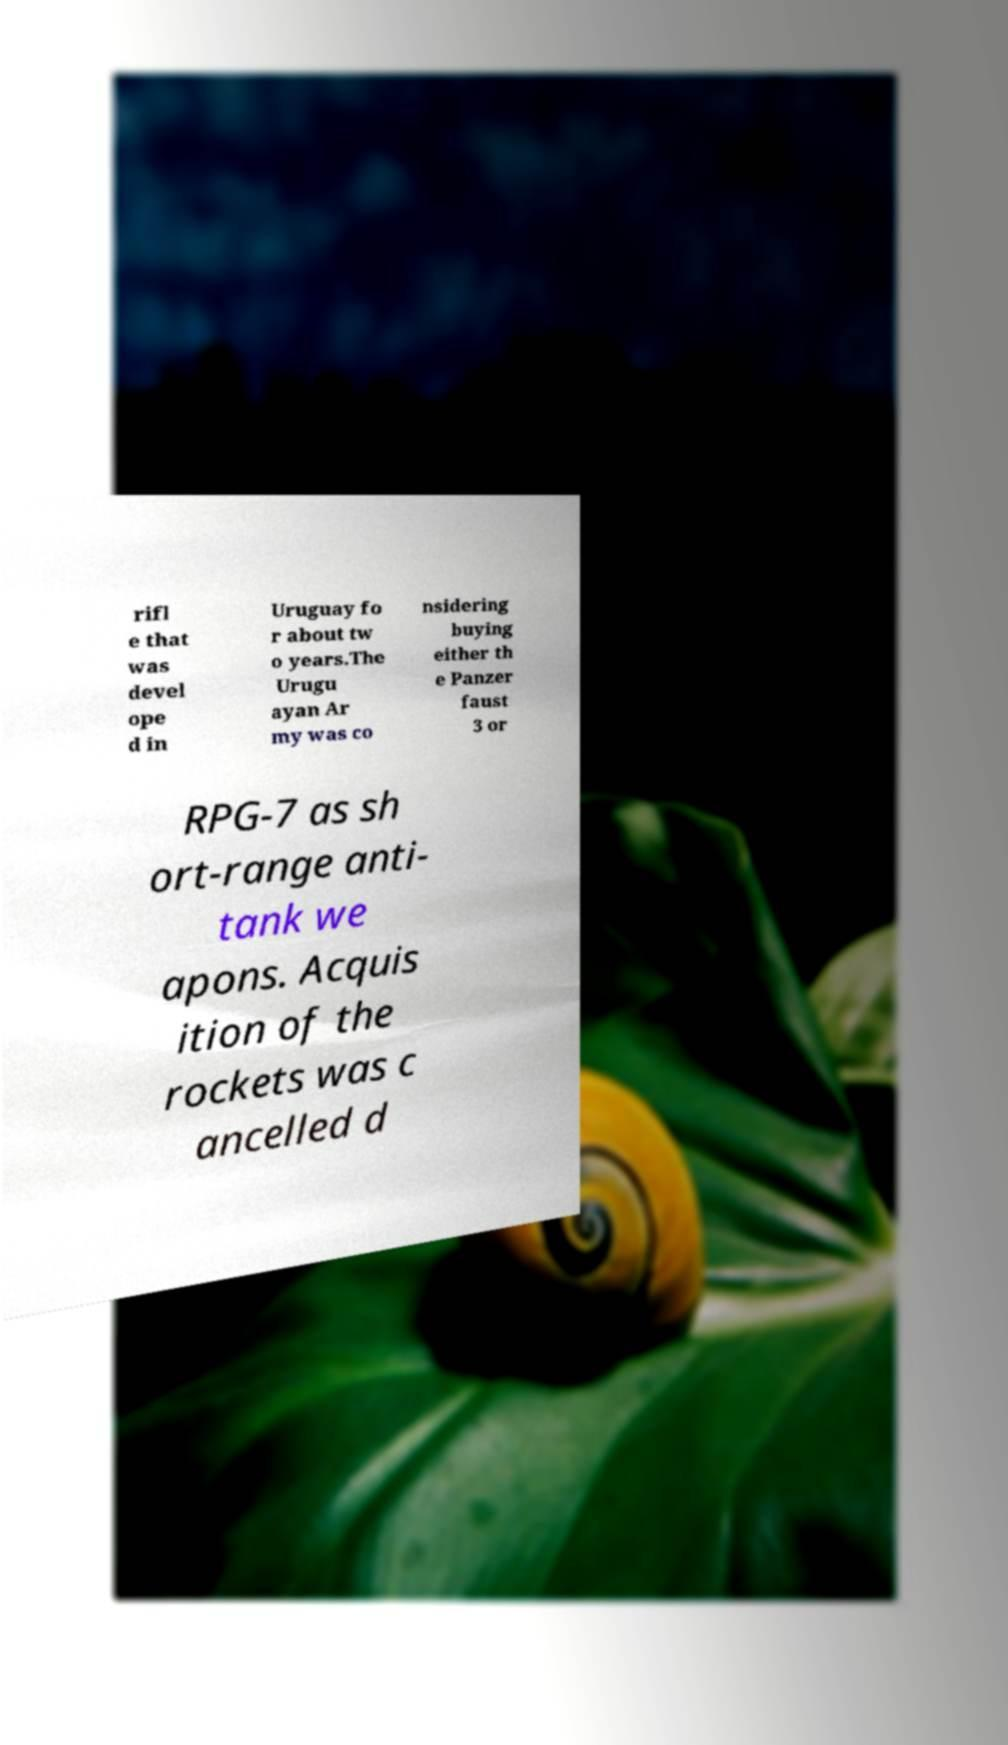There's text embedded in this image that I need extracted. Can you transcribe it verbatim? rifl e that was devel ope d in Uruguay fo r about tw o years.The Urugu ayan Ar my was co nsidering buying either th e Panzer faust 3 or RPG-7 as sh ort-range anti- tank we apons. Acquis ition of the rockets was c ancelled d 